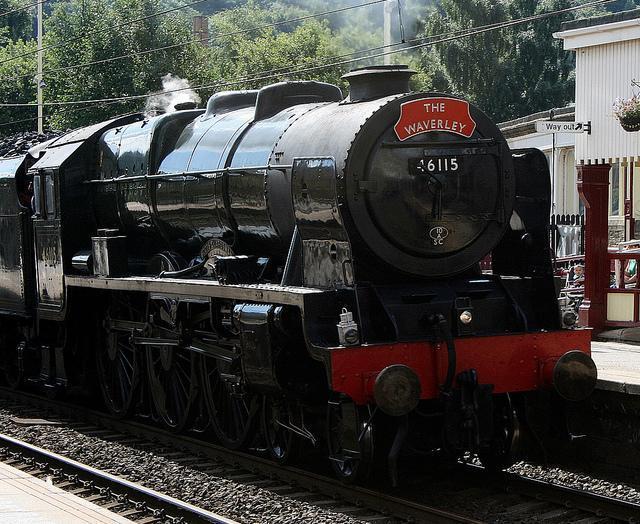How many people are in this picture?
Give a very brief answer. 0. 